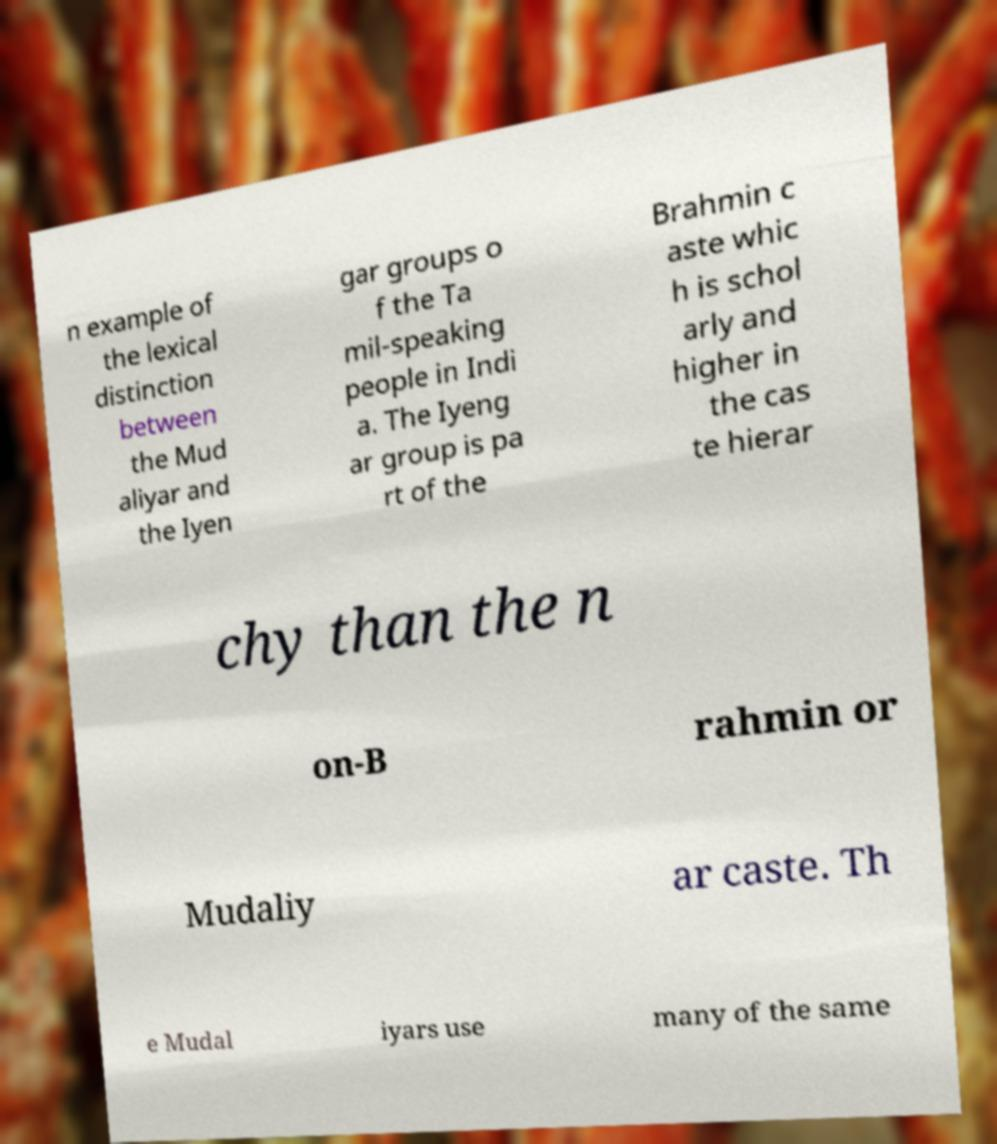Please read and relay the text visible in this image. What does it say? n example of the lexical distinction between the Mud aliyar and the Iyen gar groups o f the Ta mil-speaking people in Indi a. The Iyeng ar group is pa rt of the Brahmin c aste whic h is schol arly and higher in the cas te hierar chy than the n on-B rahmin or Mudaliy ar caste. Th e Mudal iyars use many of the same 